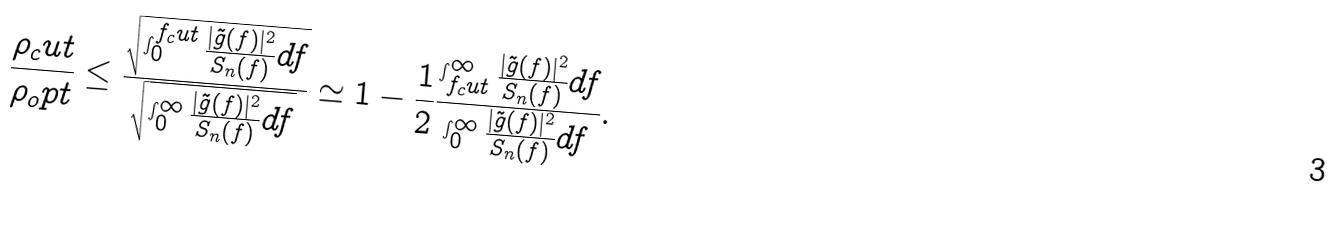<formula> <loc_0><loc_0><loc_500><loc_500>\frac { \rho _ { c } u t } { \rho _ { o } p t } \leq \frac { \sqrt { \int _ { 0 } ^ { f _ { c } u t } \frac { | \tilde { g } ( f ) | ^ { 2 } } { S _ { n } ( f ) } d f } } { \sqrt { \int _ { 0 } ^ { \infty } \frac { | \tilde { g } ( f ) | ^ { 2 } } { S _ { n } ( f ) } d f } } \simeq 1 - \frac { 1 } { 2 } \frac { \int _ { f _ { c } u t } ^ { \infty } \frac { | \tilde { g } ( f ) | ^ { 2 } } { S _ { n } ( f ) } d f } { \int _ { 0 } ^ { \infty } \frac { | \tilde { g } ( f ) | ^ { 2 } } { S _ { n } ( f ) } d f } .</formula> 